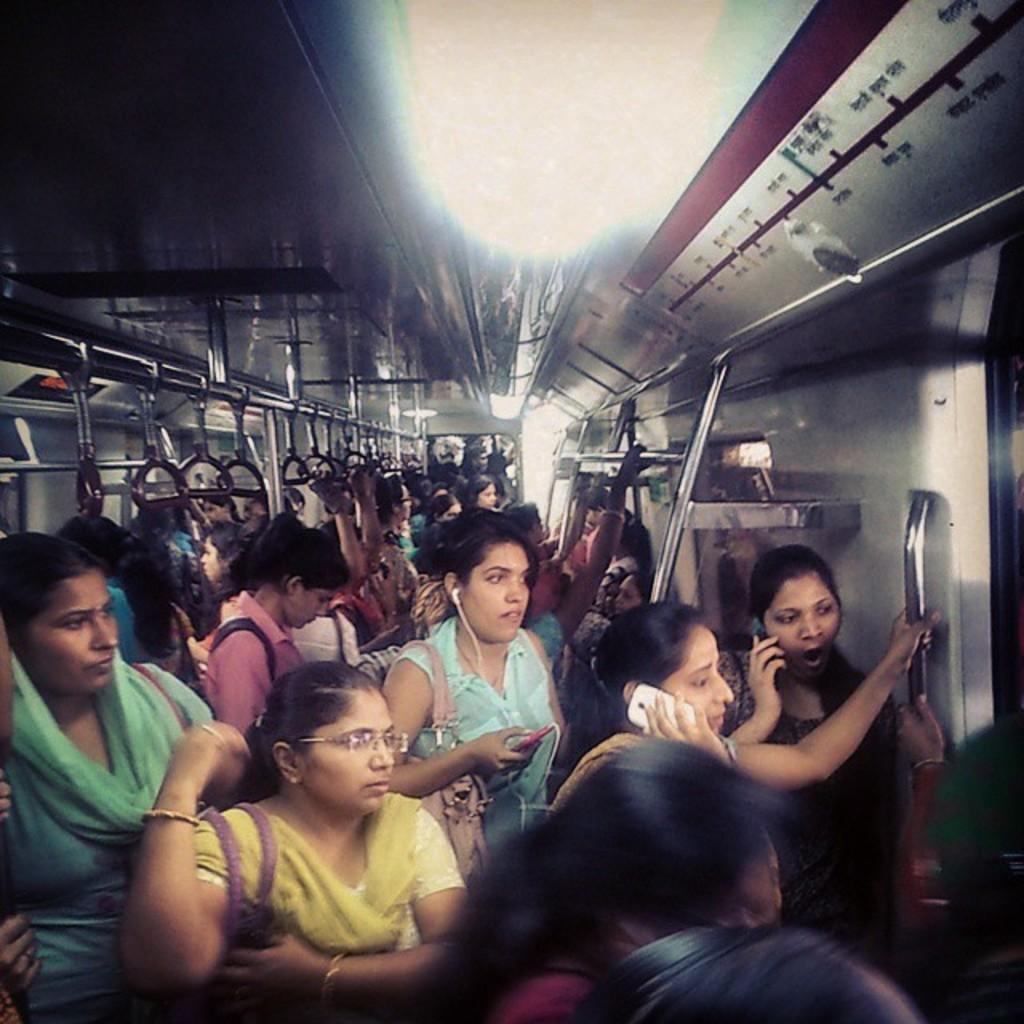What are the people in the image doing? The people in the image are standing in the train. What can be seen at the top of the image? There are lights visible at the top of the image. What type of plantation is visible in the image? There is no plantation present in the image. What size is the caption in the image? There is no caption present in the image. 